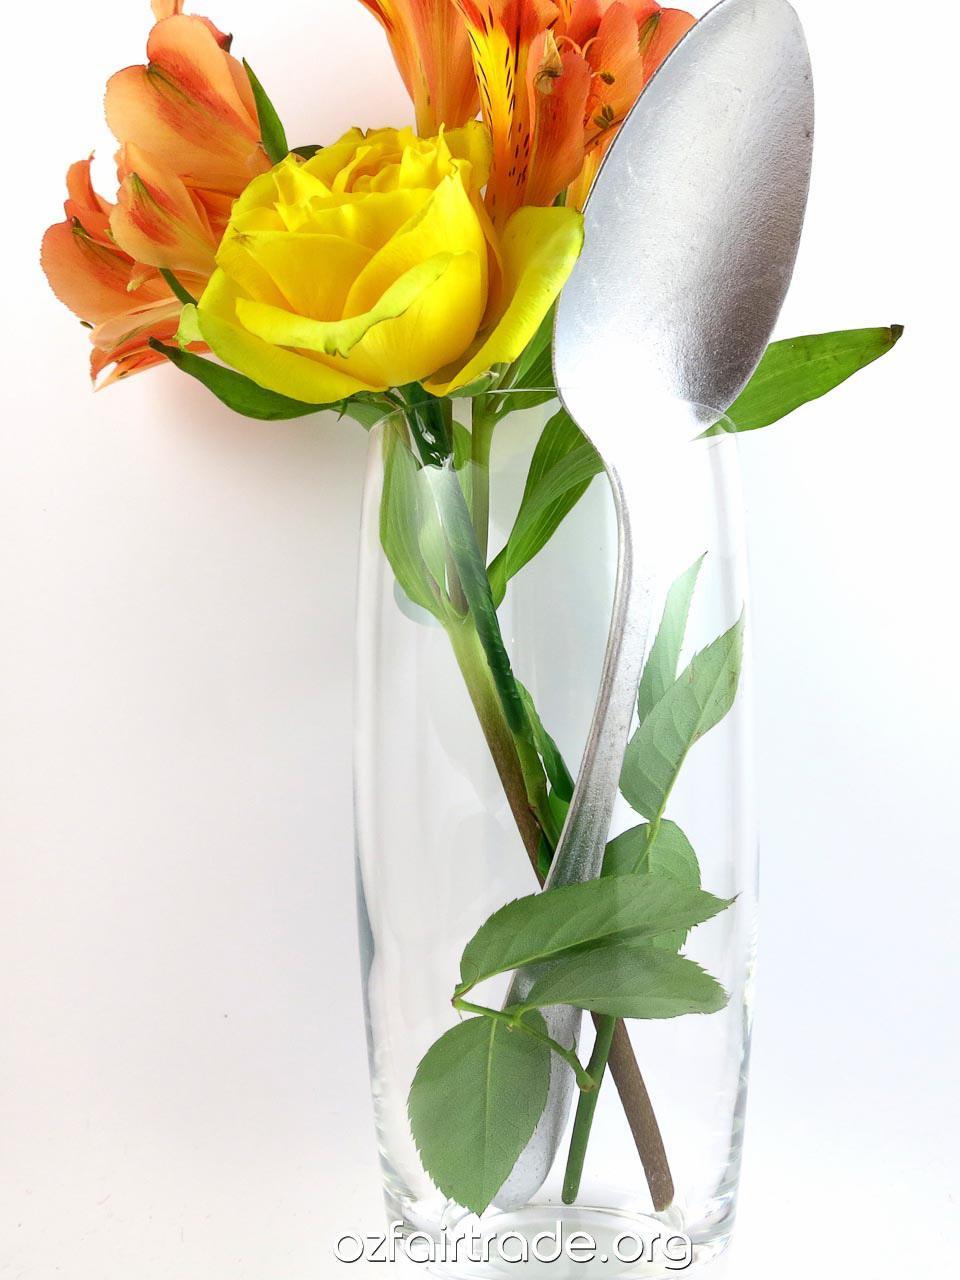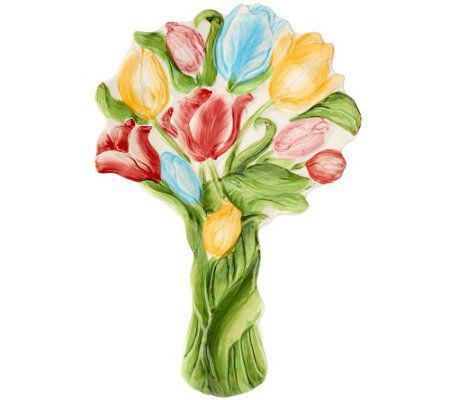The first image is the image on the left, the second image is the image on the right. For the images shown, is this caption "The left image features a square vase displayed head-on that holds only dark pink roses." true? Answer yes or no. No. The first image is the image on the left, the second image is the image on the right. Considering the images on both sides, is "The vase on the left contains all pink flowers, while the vase on the right contains at least some purple flowers." valid? Answer yes or no. No. 